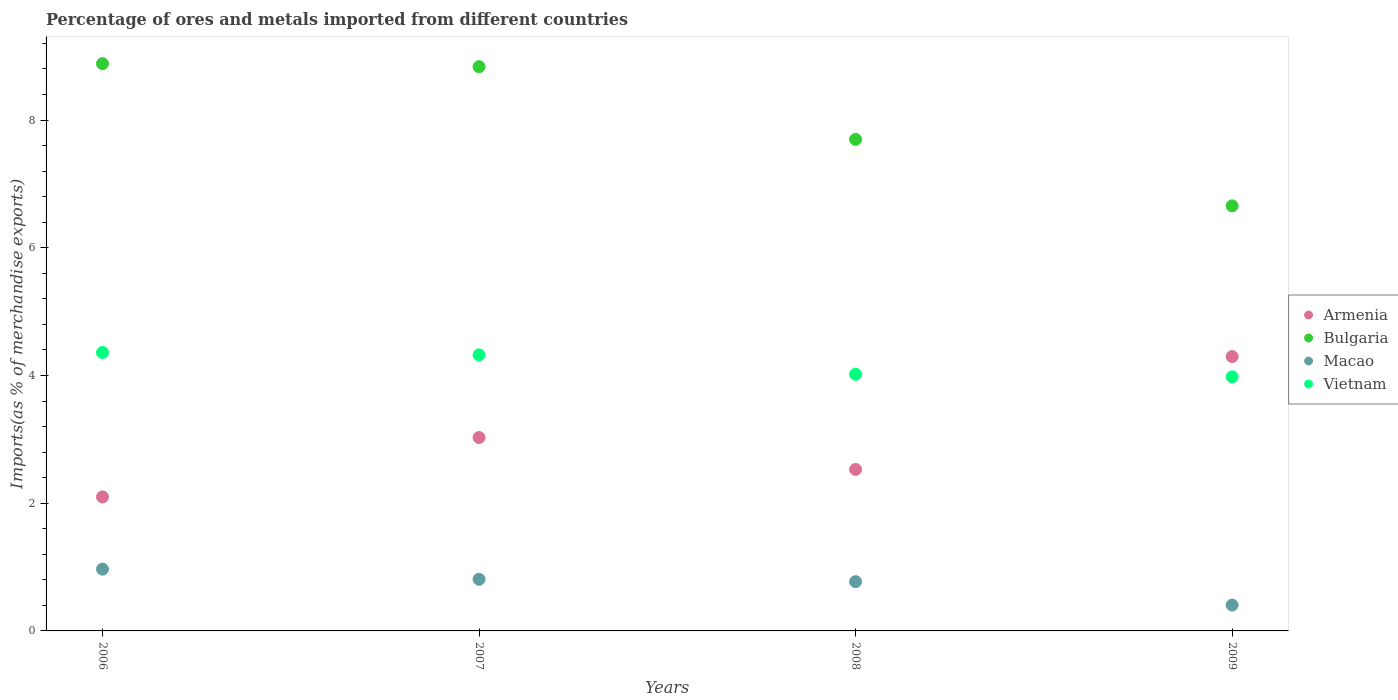Is the number of dotlines equal to the number of legend labels?
Offer a very short reply. Yes. What is the percentage of imports to different countries in Vietnam in 2009?
Your response must be concise. 3.98. Across all years, what is the maximum percentage of imports to different countries in Vietnam?
Keep it short and to the point. 4.36. Across all years, what is the minimum percentage of imports to different countries in Armenia?
Keep it short and to the point. 2.1. In which year was the percentage of imports to different countries in Armenia maximum?
Ensure brevity in your answer.  2009. In which year was the percentage of imports to different countries in Armenia minimum?
Provide a short and direct response. 2006. What is the total percentage of imports to different countries in Macao in the graph?
Provide a succinct answer. 2.95. What is the difference between the percentage of imports to different countries in Armenia in 2008 and that in 2009?
Keep it short and to the point. -1.77. What is the difference between the percentage of imports to different countries in Armenia in 2006 and the percentage of imports to different countries in Macao in 2009?
Provide a short and direct response. 1.69. What is the average percentage of imports to different countries in Armenia per year?
Offer a terse response. 2.99. In the year 2006, what is the difference between the percentage of imports to different countries in Bulgaria and percentage of imports to different countries in Vietnam?
Ensure brevity in your answer.  4.52. In how many years, is the percentage of imports to different countries in Macao greater than 6.4 %?
Ensure brevity in your answer.  0. What is the ratio of the percentage of imports to different countries in Armenia in 2008 to that in 2009?
Ensure brevity in your answer.  0.59. What is the difference between the highest and the second highest percentage of imports to different countries in Macao?
Provide a succinct answer. 0.16. What is the difference between the highest and the lowest percentage of imports to different countries in Vietnam?
Keep it short and to the point. 0.38. In how many years, is the percentage of imports to different countries in Bulgaria greater than the average percentage of imports to different countries in Bulgaria taken over all years?
Provide a succinct answer. 2. Is the sum of the percentage of imports to different countries in Bulgaria in 2006 and 2008 greater than the maximum percentage of imports to different countries in Vietnam across all years?
Make the answer very short. Yes. Is the percentage of imports to different countries in Bulgaria strictly less than the percentage of imports to different countries in Macao over the years?
Your answer should be compact. No. How many dotlines are there?
Provide a short and direct response. 4. What is the difference between two consecutive major ticks on the Y-axis?
Give a very brief answer. 2. Does the graph contain grids?
Your response must be concise. No. How many legend labels are there?
Provide a short and direct response. 4. How are the legend labels stacked?
Your answer should be very brief. Vertical. What is the title of the graph?
Make the answer very short. Percentage of ores and metals imported from different countries. What is the label or title of the X-axis?
Make the answer very short. Years. What is the label or title of the Y-axis?
Your response must be concise. Imports(as % of merchandise exports). What is the Imports(as % of merchandise exports) of Armenia in 2006?
Give a very brief answer. 2.1. What is the Imports(as % of merchandise exports) in Bulgaria in 2006?
Offer a very short reply. 8.88. What is the Imports(as % of merchandise exports) of Macao in 2006?
Offer a terse response. 0.97. What is the Imports(as % of merchandise exports) of Vietnam in 2006?
Your response must be concise. 4.36. What is the Imports(as % of merchandise exports) in Armenia in 2007?
Keep it short and to the point. 3.03. What is the Imports(as % of merchandise exports) of Bulgaria in 2007?
Your response must be concise. 8.84. What is the Imports(as % of merchandise exports) of Macao in 2007?
Your answer should be very brief. 0.81. What is the Imports(as % of merchandise exports) in Vietnam in 2007?
Your answer should be very brief. 4.32. What is the Imports(as % of merchandise exports) of Armenia in 2008?
Make the answer very short. 2.53. What is the Imports(as % of merchandise exports) in Bulgaria in 2008?
Make the answer very short. 7.7. What is the Imports(as % of merchandise exports) in Macao in 2008?
Provide a succinct answer. 0.77. What is the Imports(as % of merchandise exports) in Vietnam in 2008?
Provide a short and direct response. 4.02. What is the Imports(as % of merchandise exports) in Armenia in 2009?
Offer a terse response. 4.3. What is the Imports(as % of merchandise exports) of Bulgaria in 2009?
Provide a short and direct response. 6.66. What is the Imports(as % of merchandise exports) in Macao in 2009?
Provide a short and direct response. 0.4. What is the Imports(as % of merchandise exports) of Vietnam in 2009?
Make the answer very short. 3.98. Across all years, what is the maximum Imports(as % of merchandise exports) in Armenia?
Make the answer very short. 4.3. Across all years, what is the maximum Imports(as % of merchandise exports) of Bulgaria?
Your response must be concise. 8.88. Across all years, what is the maximum Imports(as % of merchandise exports) in Macao?
Provide a succinct answer. 0.97. Across all years, what is the maximum Imports(as % of merchandise exports) of Vietnam?
Your answer should be compact. 4.36. Across all years, what is the minimum Imports(as % of merchandise exports) in Armenia?
Offer a terse response. 2.1. Across all years, what is the minimum Imports(as % of merchandise exports) in Bulgaria?
Offer a very short reply. 6.66. Across all years, what is the minimum Imports(as % of merchandise exports) in Macao?
Make the answer very short. 0.4. Across all years, what is the minimum Imports(as % of merchandise exports) of Vietnam?
Give a very brief answer. 3.98. What is the total Imports(as % of merchandise exports) of Armenia in the graph?
Ensure brevity in your answer.  11.95. What is the total Imports(as % of merchandise exports) in Bulgaria in the graph?
Offer a terse response. 32.07. What is the total Imports(as % of merchandise exports) of Macao in the graph?
Provide a short and direct response. 2.95. What is the total Imports(as % of merchandise exports) of Vietnam in the graph?
Your response must be concise. 16.68. What is the difference between the Imports(as % of merchandise exports) of Armenia in 2006 and that in 2007?
Ensure brevity in your answer.  -0.93. What is the difference between the Imports(as % of merchandise exports) in Bulgaria in 2006 and that in 2007?
Ensure brevity in your answer.  0.05. What is the difference between the Imports(as % of merchandise exports) of Macao in 2006 and that in 2007?
Offer a terse response. 0.16. What is the difference between the Imports(as % of merchandise exports) in Vietnam in 2006 and that in 2007?
Give a very brief answer. 0.04. What is the difference between the Imports(as % of merchandise exports) of Armenia in 2006 and that in 2008?
Keep it short and to the point. -0.43. What is the difference between the Imports(as % of merchandise exports) of Bulgaria in 2006 and that in 2008?
Provide a succinct answer. 1.19. What is the difference between the Imports(as % of merchandise exports) of Macao in 2006 and that in 2008?
Give a very brief answer. 0.2. What is the difference between the Imports(as % of merchandise exports) of Vietnam in 2006 and that in 2008?
Your response must be concise. 0.34. What is the difference between the Imports(as % of merchandise exports) in Armenia in 2006 and that in 2009?
Your answer should be compact. -2.2. What is the difference between the Imports(as % of merchandise exports) of Bulgaria in 2006 and that in 2009?
Make the answer very short. 2.23. What is the difference between the Imports(as % of merchandise exports) of Macao in 2006 and that in 2009?
Your answer should be compact. 0.56. What is the difference between the Imports(as % of merchandise exports) of Vietnam in 2006 and that in 2009?
Give a very brief answer. 0.38. What is the difference between the Imports(as % of merchandise exports) of Armenia in 2007 and that in 2008?
Provide a short and direct response. 0.5. What is the difference between the Imports(as % of merchandise exports) in Bulgaria in 2007 and that in 2008?
Ensure brevity in your answer.  1.14. What is the difference between the Imports(as % of merchandise exports) in Macao in 2007 and that in 2008?
Give a very brief answer. 0.04. What is the difference between the Imports(as % of merchandise exports) of Vietnam in 2007 and that in 2008?
Offer a very short reply. 0.3. What is the difference between the Imports(as % of merchandise exports) in Armenia in 2007 and that in 2009?
Give a very brief answer. -1.27. What is the difference between the Imports(as % of merchandise exports) in Bulgaria in 2007 and that in 2009?
Ensure brevity in your answer.  2.18. What is the difference between the Imports(as % of merchandise exports) of Macao in 2007 and that in 2009?
Your answer should be compact. 0.4. What is the difference between the Imports(as % of merchandise exports) of Vietnam in 2007 and that in 2009?
Offer a very short reply. 0.34. What is the difference between the Imports(as % of merchandise exports) of Armenia in 2008 and that in 2009?
Offer a terse response. -1.77. What is the difference between the Imports(as % of merchandise exports) of Bulgaria in 2008 and that in 2009?
Your response must be concise. 1.04. What is the difference between the Imports(as % of merchandise exports) in Macao in 2008 and that in 2009?
Offer a very short reply. 0.37. What is the difference between the Imports(as % of merchandise exports) of Vietnam in 2008 and that in 2009?
Give a very brief answer. 0.04. What is the difference between the Imports(as % of merchandise exports) in Armenia in 2006 and the Imports(as % of merchandise exports) in Bulgaria in 2007?
Your answer should be compact. -6.74. What is the difference between the Imports(as % of merchandise exports) of Armenia in 2006 and the Imports(as % of merchandise exports) of Macao in 2007?
Make the answer very short. 1.29. What is the difference between the Imports(as % of merchandise exports) in Armenia in 2006 and the Imports(as % of merchandise exports) in Vietnam in 2007?
Provide a succinct answer. -2.23. What is the difference between the Imports(as % of merchandise exports) of Bulgaria in 2006 and the Imports(as % of merchandise exports) of Macao in 2007?
Provide a short and direct response. 8.07. What is the difference between the Imports(as % of merchandise exports) of Bulgaria in 2006 and the Imports(as % of merchandise exports) of Vietnam in 2007?
Keep it short and to the point. 4.56. What is the difference between the Imports(as % of merchandise exports) of Macao in 2006 and the Imports(as % of merchandise exports) of Vietnam in 2007?
Make the answer very short. -3.36. What is the difference between the Imports(as % of merchandise exports) in Armenia in 2006 and the Imports(as % of merchandise exports) in Bulgaria in 2008?
Provide a succinct answer. -5.6. What is the difference between the Imports(as % of merchandise exports) in Armenia in 2006 and the Imports(as % of merchandise exports) in Macao in 2008?
Your response must be concise. 1.33. What is the difference between the Imports(as % of merchandise exports) of Armenia in 2006 and the Imports(as % of merchandise exports) of Vietnam in 2008?
Keep it short and to the point. -1.92. What is the difference between the Imports(as % of merchandise exports) in Bulgaria in 2006 and the Imports(as % of merchandise exports) in Macao in 2008?
Ensure brevity in your answer.  8.11. What is the difference between the Imports(as % of merchandise exports) of Bulgaria in 2006 and the Imports(as % of merchandise exports) of Vietnam in 2008?
Your answer should be compact. 4.86. What is the difference between the Imports(as % of merchandise exports) in Macao in 2006 and the Imports(as % of merchandise exports) in Vietnam in 2008?
Give a very brief answer. -3.05. What is the difference between the Imports(as % of merchandise exports) in Armenia in 2006 and the Imports(as % of merchandise exports) in Bulgaria in 2009?
Provide a short and direct response. -4.56. What is the difference between the Imports(as % of merchandise exports) of Armenia in 2006 and the Imports(as % of merchandise exports) of Macao in 2009?
Provide a short and direct response. 1.69. What is the difference between the Imports(as % of merchandise exports) in Armenia in 2006 and the Imports(as % of merchandise exports) in Vietnam in 2009?
Your answer should be compact. -1.88. What is the difference between the Imports(as % of merchandise exports) in Bulgaria in 2006 and the Imports(as % of merchandise exports) in Macao in 2009?
Your response must be concise. 8.48. What is the difference between the Imports(as % of merchandise exports) of Bulgaria in 2006 and the Imports(as % of merchandise exports) of Vietnam in 2009?
Give a very brief answer. 4.9. What is the difference between the Imports(as % of merchandise exports) of Macao in 2006 and the Imports(as % of merchandise exports) of Vietnam in 2009?
Your answer should be very brief. -3.01. What is the difference between the Imports(as % of merchandise exports) of Armenia in 2007 and the Imports(as % of merchandise exports) of Bulgaria in 2008?
Your answer should be very brief. -4.67. What is the difference between the Imports(as % of merchandise exports) in Armenia in 2007 and the Imports(as % of merchandise exports) in Macao in 2008?
Offer a very short reply. 2.26. What is the difference between the Imports(as % of merchandise exports) in Armenia in 2007 and the Imports(as % of merchandise exports) in Vietnam in 2008?
Your answer should be very brief. -0.99. What is the difference between the Imports(as % of merchandise exports) of Bulgaria in 2007 and the Imports(as % of merchandise exports) of Macao in 2008?
Offer a terse response. 8.06. What is the difference between the Imports(as % of merchandise exports) of Bulgaria in 2007 and the Imports(as % of merchandise exports) of Vietnam in 2008?
Keep it short and to the point. 4.82. What is the difference between the Imports(as % of merchandise exports) of Macao in 2007 and the Imports(as % of merchandise exports) of Vietnam in 2008?
Your answer should be compact. -3.21. What is the difference between the Imports(as % of merchandise exports) in Armenia in 2007 and the Imports(as % of merchandise exports) in Bulgaria in 2009?
Provide a short and direct response. -3.63. What is the difference between the Imports(as % of merchandise exports) in Armenia in 2007 and the Imports(as % of merchandise exports) in Macao in 2009?
Provide a succinct answer. 2.62. What is the difference between the Imports(as % of merchandise exports) in Armenia in 2007 and the Imports(as % of merchandise exports) in Vietnam in 2009?
Keep it short and to the point. -0.95. What is the difference between the Imports(as % of merchandise exports) in Bulgaria in 2007 and the Imports(as % of merchandise exports) in Macao in 2009?
Your answer should be compact. 8.43. What is the difference between the Imports(as % of merchandise exports) of Bulgaria in 2007 and the Imports(as % of merchandise exports) of Vietnam in 2009?
Keep it short and to the point. 4.86. What is the difference between the Imports(as % of merchandise exports) of Macao in 2007 and the Imports(as % of merchandise exports) of Vietnam in 2009?
Ensure brevity in your answer.  -3.17. What is the difference between the Imports(as % of merchandise exports) in Armenia in 2008 and the Imports(as % of merchandise exports) in Bulgaria in 2009?
Your answer should be very brief. -4.13. What is the difference between the Imports(as % of merchandise exports) in Armenia in 2008 and the Imports(as % of merchandise exports) in Macao in 2009?
Provide a short and direct response. 2.12. What is the difference between the Imports(as % of merchandise exports) of Armenia in 2008 and the Imports(as % of merchandise exports) of Vietnam in 2009?
Your response must be concise. -1.45. What is the difference between the Imports(as % of merchandise exports) in Bulgaria in 2008 and the Imports(as % of merchandise exports) in Macao in 2009?
Your answer should be very brief. 7.29. What is the difference between the Imports(as % of merchandise exports) in Bulgaria in 2008 and the Imports(as % of merchandise exports) in Vietnam in 2009?
Ensure brevity in your answer.  3.72. What is the difference between the Imports(as % of merchandise exports) in Macao in 2008 and the Imports(as % of merchandise exports) in Vietnam in 2009?
Ensure brevity in your answer.  -3.21. What is the average Imports(as % of merchandise exports) in Armenia per year?
Your answer should be very brief. 2.99. What is the average Imports(as % of merchandise exports) in Bulgaria per year?
Ensure brevity in your answer.  8.02. What is the average Imports(as % of merchandise exports) in Macao per year?
Provide a short and direct response. 0.74. What is the average Imports(as % of merchandise exports) of Vietnam per year?
Your answer should be very brief. 4.17. In the year 2006, what is the difference between the Imports(as % of merchandise exports) in Armenia and Imports(as % of merchandise exports) in Bulgaria?
Offer a terse response. -6.79. In the year 2006, what is the difference between the Imports(as % of merchandise exports) of Armenia and Imports(as % of merchandise exports) of Macao?
Keep it short and to the point. 1.13. In the year 2006, what is the difference between the Imports(as % of merchandise exports) of Armenia and Imports(as % of merchandise exports) of Vietnam?
Your answer should be compact. -2.26. In the year 2006, what is the difference between the Imports(as % of merchandise exports) of Bulgaria and Imports(as % of merchandise exports) of Macao?
Ensure brevity in your answer.  7.92. In the year 2006, what is the difference between the Imports(as % of merchandise exports) of Bulgaria and Imports(as % of merchandise exports) of Vietnam?
Offer a terse response. 4.52. In the year 2006, what is the difference between the Imports(as % of merchandise exports) of Macao and Imports(as % of merchandise exports) of Vietnam?
Ensure brevity in your answer.  -3.39. In the year 2007, what is the difference between the Imports(as % of merchandise exports) of Armenia and Imports(as % of merchandise exports) of Bulgaria?
Your response must be concise. -5.81. In the year 2007, what is the difference between the Imports(as % of merchandise exports) in Armenia and Imports(as % of merchandise exports) in Macao?
Offer a very short reply. 2.22. In the year 2007, what is the difference between the Imports(as % of merchandise exports) in Armenia and Imports(as % of merchandise exports) in Vietnam?
Your answer should be very brief. -1.29. In the year 2007, what is the difference between the Imports(as % of merchandise exports) in Bulgaria and Imports(as % of merchandise exports) in Macao?
Offer a terse response. 8.03. In the year 2007, what is the difference between the Imports(as % of merchandise exports) of Bulgaria and Imports(as % of merchandise exports) of Vietnam?
Provide a succinct answer. 4.51. In the year 2007, what is the difference between the Imports(as % of merchandise exports) in Macao and Imports(as % of merchandise exports) in Vietnam?
Provide a succinct answer. -3.51. In the year 2008, what is the difference between the Imports(as % of merchandise exports) of Armenia and Imports(as % of merchandise exports) of Bulgaria?
Offer a terse response. -5.17. In the year 2008, what is the difference between the Imports(as % of merchandise exports) in Armenia and Imports(as % of merchandise exports) in Macao?
Ensure brevity in your answer.  1.76. In the year 2008, what is the difference between the Imports(as % of merchandise exports) in Armenia and Imports(as % of merchandise exports) in Vietnam?
Provide a succinct answer. -1.49. In the year 2008, what is the difference between the Imports(as % of merchandise exports) in Bulgaria and Imports(as % of merchandise exports) in Macao?
Provide a succinct answer. 6.93. In the year 2008, what is the difference between the Imports(as % of merchandise exports) of Bulgaria and Imports(as % of merchandise exports) of Vietnam?
Make the answer very short. 3.68. In the year 2008, what is the difference between the Imports(as % of merchandise exports) of Macao and Imports(as % of merchandise exports) of Vietnam?
Your response must be concise. -3.25. In the year 2009, what is the difference between the Imports(as % of merchandise exports) in Armenia and Imports(as % of merchandise exports) in Bulgaria?
Your answer should be compact. -2.36. In the year 2009, what is the difference between the Imports(as % of merchandise exports) in Armenia and Imports(as % of merchandise exports) in Macao?
Offer a very short reply. 3.89. In the year 2009, what is the difference between the Imports(as % of merchandise exports) in Armenia and Imports(as % of merchandise exports) in Vietnam?
Your response must be concise. 0.32. In the year 2009, what is the difference between the Imports(as % of merchandise exports) of Bulgaria and Imports(as % of merchandise exports) of Macao?
Your answer should be very brief. 6.25. In the year 2009, what is the difference between the Imports(as % of merchandise exports) in Bulgaria and Imports(as % of merchandise exports) in Vietnam?
Your response must be concise. 2.68. In the year 2009, what is the difference between the Imports(as % of merchandise exports) in Macao and Imports(as % of merchandise exports) in Vietnam?
Ensure brevity in your answer.  -3.57. What is the ratio of the Imports(as % of merchandise exports) of Armenia in 2006 to that in 2007?
Give a very brief answer. 0.69. What is the ratio of the Imports(as % of merchandise exports) of Bulgaria in 2006 to that in 2007?
Keep it short and to the point. 1.01. What is the ratio of the Imports(as % of merchandise exports) in Macao in 2006 to that in 2007?
Give a very brief answer. 1.2. What is the ratio of the Imports(as % of merchandise exports) of Vietnam in 2006 to that in 2007?
Make the answer very short. 1.01. What is the ratio of the Imports(as % of merchandise exports) of Armenia in 2006 to that in 2008?
Your answer should be compact. 0.83. What is the ratio of the Imports(as % of merchandise exports) of Bulgaria in 2006 to that in 2008?
Your response must be concise. 1.15. What is the ratio of the Imports(as % of merchandise exports) of Macao in 2006 to that in 2008?
Your answer should be compact. 1.25. What is the ratio of the Imports(as % of merchandise exports) of Vietnam in 2006 to that in 2008?
Offer a very short reply. 1.08. What is the ratio of the Imports(as % of merchandise exports) in Armenia in 2006 to that in 2009?
Give a very brief answer. 0.49. What is the ratio of the Imports(as % of merchandise exports) of Bulgaria in 2006 to that in 2009?
Keep it short and to the point. 1.33. What is the ratio of the Imports(as % of merchandise exports) in Macao in 2006 to that in 2009?
Provide a short and direct response. 2.39. What is the ratio of the Imports(as % of merchandise exports) of Vietnam in 2006 to that in 2009?
Your response must be concise. 1.1. What is the ratio of the Imports(as % of merchandise exports) in Armenia in 2007 to that in 2008?
Make the answer very short. 1.2. What is the ratio of the Imports(as % of merchandise exports) in Bulgaria in 2007 to that in 2008?
Offer a terse response. 1.15. What is the ratio of the Imports(as % of merchandise exports) of Macao in 2007 to that in 2008?
Your answer should be compact. 1.05. What is the ratio of the Imports(as % of merchandise exports) in Vietnam in 2007 to that in 2008?
Offer a terse response. 1.08. What is the ratio of the Imports(as % of merchandise exports) of Armenia in 2007 to that in 2009?
Keep it short and to the point. 0.7. What is the ratio of the Imports(as % of merchandise exports) of Bulgaria in 2007 to that in 2009?
Keep it short and to the point. 1.33. What is the ratio of the Imports(as % of merchandise exports) in Macao in 2007 to that in 2009?
Keep it short and to the point. 2. What is the ratio of the Imports(as % of merchandise exports) in Vietnam in 2007 to that in 2009?
Make the answer very short. 1.09. What is the ratio of the Imports(as % of merchandise exports) in Armenia in 2008 to that in 2009?
Offer a very short reply. 0.59. What is the ratio of the Imports(as % of merchandise exports) in Bulgaria in 2008 to that in 2009?
Make the answer very short. 1.16. What is the ratio of the Imports(as % of merchandise exports) in Macao in 2008 to that in 2009?
Your answer should be compact. 1.91. What is the ratio of the Imports(as % of merchandise exports) of Vietnam in 2008 to that in 2009?
Your response must be concise. 1.01. What is the difference between the highest and the second highest Imports(as % of merchandise exports) of Armenia?
Provide a succinct answer. 1.27. What is the difference between the highest and the second highest Imports(as % of merchandise exports) in Bulgaria?
Make the answer very short. 0.05. What is the difference between the highest and the second highest Imports(as % of merchandise exports) in Macao?
Provide a short and direct response. 0.16. What is the difference between the highest and the second highest Imports(as % of merchandise exports) in Vietnam?
Give a very brief answer. 0.04. What is the difference between the highest and the lowest Imports(as % of merchandise exports) of Armenia?
Provide a succinct answer. 2.2. What is the difference between the highest and the lowest Imports(as % of merchandise exports) of Bulgaria?
Provide a short and direct response. 2.23. What is the difference between the highest and the lowest Imports(as % of merchandise exports) of Macao?
Your response must be concise. 0.56. What is the difference between the highest and the lowest Imports(as % of merchandise exports) of Vietnam?
Provide a short and direct response. 0.38. 